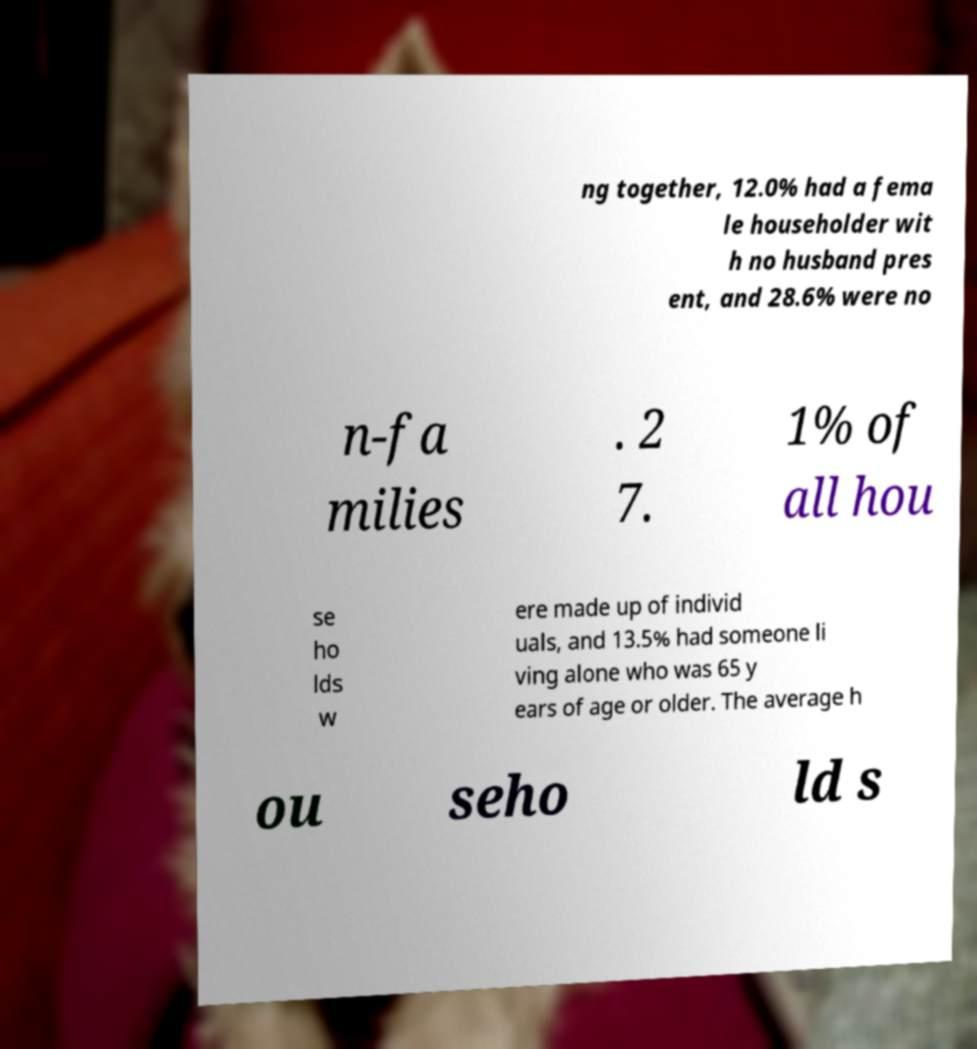Can you read and provide the text displayed in the image?This photo seems to have some interesting text. Can you extract and type it out for me? ng together, 12.0% had a fema le householder wit h no husband pres ent, and 28.6% were no n-fa milies . 2 7. 1% of all hou se ho lds w ere made up of individ uals, and 13.5% had someone li ving alone who was 65 y ears of age or older. The average h ou seho ld s 